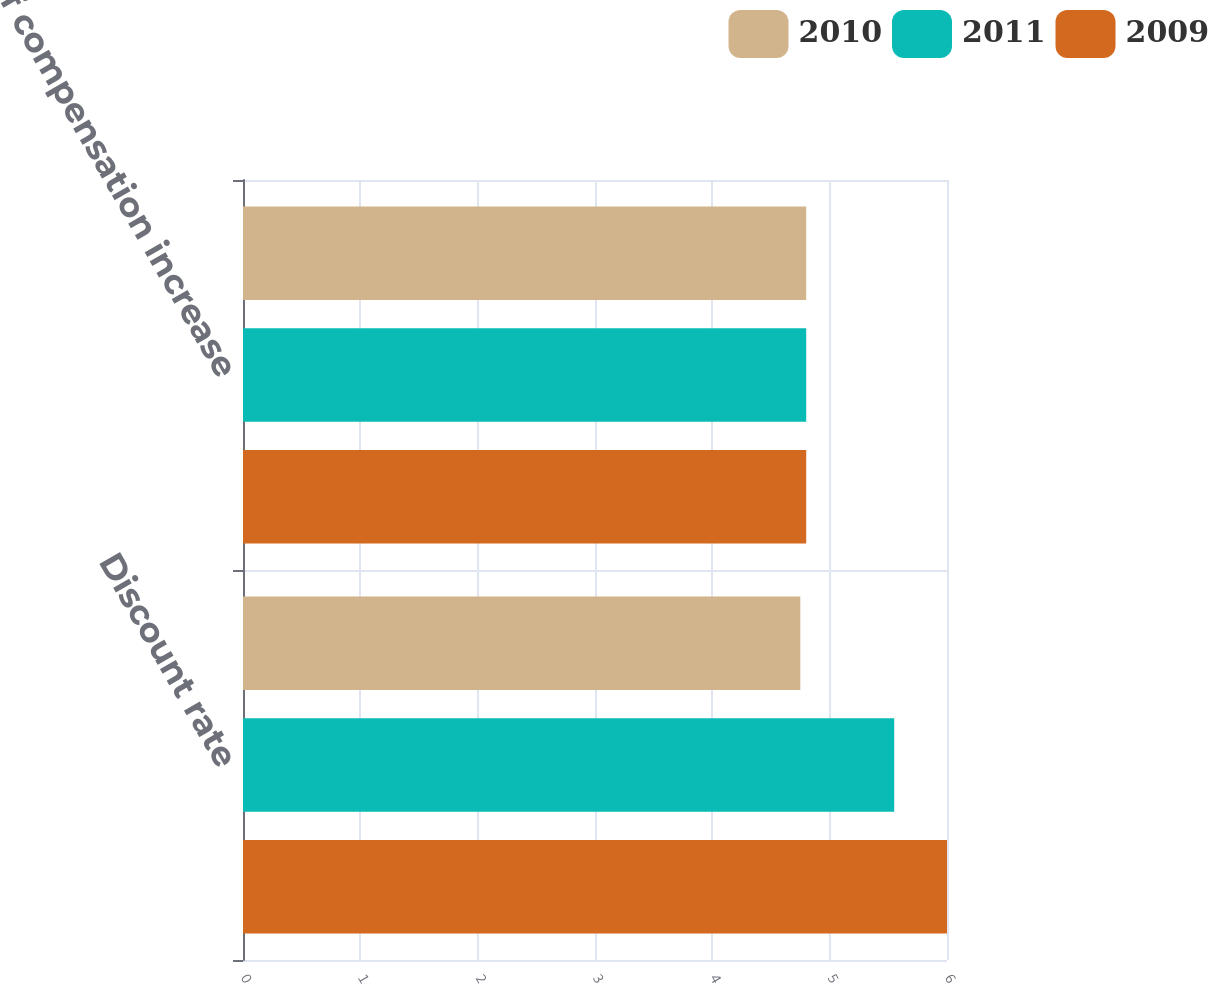Convert chart to OTSL. <chart><loc_0><loc_0><loc_500><loc_500><stacked_bar_chart><ecel><fcel>Discount rate<fcel>Rate of compensation increase<nl><fcel>2010<fcel>4.75<fcel>4.8<nl><fcel>2011<fcel>5.55<fcel>4.8<nl><fcel>2009<fcel>6<fcel>4.8<nl></chart> 